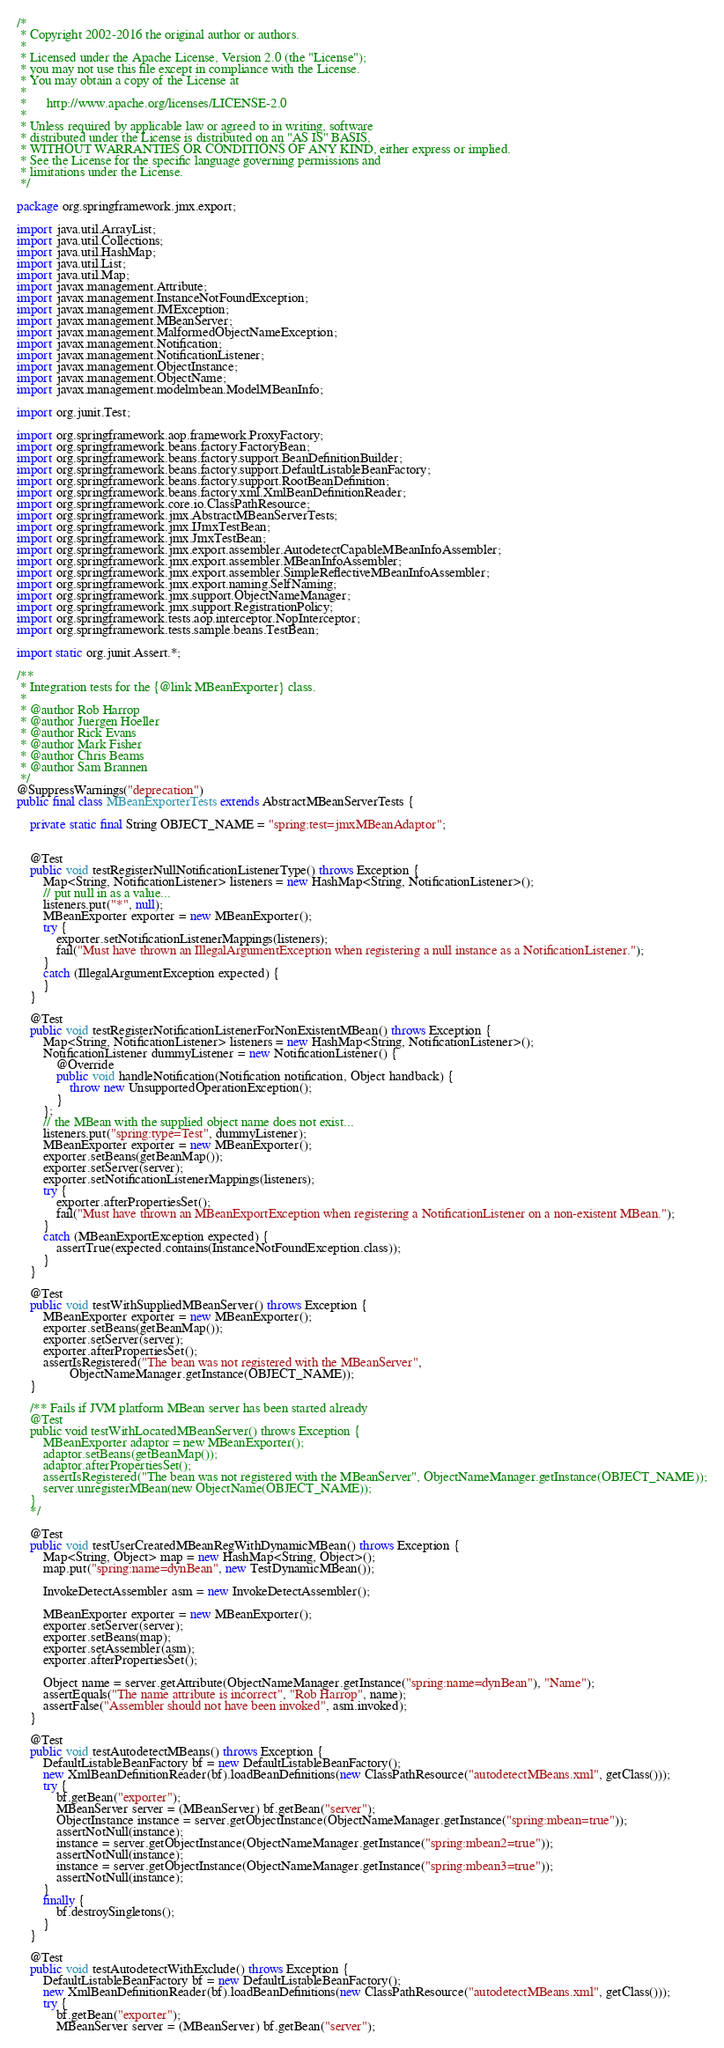Convert code to text. <code><loc_0><loc_0><loc_500><loc_500><_Java_>/*
 * Copyright 2002-2016 the original author or authors.
 *
 * Licensed under the Apache License, Version 2.0 (the "License");
 * you may not use this file except in compliance with the License.
 * You may obtain a copy of the License at
 *
 *      http://www.apache.org/licenses/LICENSE-2.0
 *
 * Unless required by applicable law or agreed to in writing, software
 * distributed under the License is distributed on an "AS IS" BASIS,
 * WITHOUT WARRANTIES OR CONDITIONS OF ANY KIND, either express or implied.
 * See the License for the specific language governing permissions and
 * limitations under the License.
 */

package org.springframework.jmx.export;

import java.util.ArrayList;
import java.util.Collections;
import java.util.HashMap;
import java.util.List;
import java.util.Map;
import javax.management.Attribute;
import javax.management.InstanceNotFoundException;
import javax.management.JMException;
import javax.management.MBeanServer;
import javax.management.MalformedObjectNameException;
import javax.management.Notification;
import javax.management.NotificationListener;
import javax.management.ObjectInstance;
import javax.management.ObjectName;
import javax.management.modelmbean.ModelMBeanInfo;

import org.junit.Test;

import org.springframework.aop.framework.ProxyFactory;
import org.springframework.beans.factory.FactoryBean;
import org.springframework.beans.factory.support.BeanDefinitionBuilder;
import org.springframework.beans.factory.support.DefaultListableBeanFactory;
import org.springframework.beans.factory.support.RootBeanDefinition;
import org.springframework.beans.factory.xml.XmlBeanDefinitionReader;
import org.springframework.core.io.ClassPathResource;
import org.springframework.jmx.AbstractMBeanServerTests;
import org.springframework.jmx.IJmxTestBean;
import org.springframework.jmx.JmxTestBean;
import org.springframework.jmx.export.assembler.AutodetectCapableMBeanInfoAssembler;
import org.springframework.jmx.export.assembler.MBeanInfoAssembler;
import org.springframework.jmx.export.assembler.SimpleReflectiveMBeanInfoAssembler;
import org.springframework.jmx.export.naming.SelfNaming;
import org.springframework.jmx.support.ObjectNameManager;
import org.springframework.jmx.support.RegistrationPolicy;
import org.springframework.tests.aop.interceptor.NopInterceptor;
import org.springframework.tests.sample.beans.TestBean;

import static org.junit.Assert.*;

/**
 * Integration tests for the {@link MBeanExporter} class.
 *
 * @author Rob Harrop
 * @author Juergen Hoeller
 * @author Rick Evans
 * @author Mark Fisher
 * @author Chris Beams
 * @author Sam Brannen
 */
@SuppressWarnings("deprecation")
public final class MBeanExporterTests extends AbstractMBeanServerTests {

	private static final String OBJECT_NAME = "spring:test=jmxMBeanAdaptor";


	@Test
	public void testRegisterNullNotificationListenerType() throws Exception {
		Map<String, NotificationListener> listeners = new HashMap<String, NotificationListener>();
		// put null in as a value...
		listeners.put("*", null);
		MBeanExporter exporter = new MBeanExporter();
		try {
			exporter.setNotificationListenerMappings(listeners);
			fail("Must have thrown an IllegalArgumentException when registering a null instance as a NotificationListener.");
		}
		catch (IllegalArgumentException expected) {
		}
	}

	@Test
	public void testRegisterNotificationListenerForNonExistentMBean() throws Exception {
		Map<String, NotificationListener> listeners = new HashMap<String, NotificationListener>();
		NotificationListener dummyListener = new NotificationListener() {
			@Override
			public void handleNotification(Notification notification, Object handback) {
				throw new UnsupportedOperationException();
			}
		};
		// the MBean with the supplied object name does not exist...
		listeners.put("spring:type=Test", dummyListener);
		MBeanExporter exporter = new MBeanExporter();
		exporter.setBeans(getBeanMap());
		exporter.setServer(server);
		exporter.setNotificationListenerMappings(listeners);
		try {
			exporter.afterPropertiesSet();
			fail("Must have thrown an MBeanExportException when registering a NotificationListener on a non-existent MBean.");
		}
		catch (MBeanExportException expected) {
			assertTrue(expected.contains(InstanceNotFoundException.class));
		}
	}

	@Test
	public void testWithSuppliedMBeanServer() throws Exception {
		MBeanExporter exporter = new MBeanExporter();
		exporter.setBeans(getBeanMap());
		exporter.setServer(server);
		exporter.afterPropertiesSet();
		assertIsRegistered("The bean was not registered with the MBeanServer",
				ObjectNameManager.getInstance(OBJECT_NAME));
	}

	/** Fails if JVM platform MBean server has been started already
	@Test
	public void testWithLocatedMBeanServer() throws Exception {
		MBeanExporter adaptor = new MBeanExporter();
		adaptor.setBeans(getBeanMap());
		adaptor.afterPropertiesSet();
		assertIsRegistered("The bean was not registered with the MBeanServer", ObjectNameManager.getInstance(OBJECT_NAME));
		server.unregisterMBean(new ObjectName(OBJECT_NAME));
	}
	*/

	@Test
	public void testUserCreatedMBeanRegWithDynamicMBean() throws Exception {
		Map<String, Object> map = new HashMap<String, Object>();
		map.put("spring:name=dynBean", new TestDynamicMBean());

		InvokeDetectAssembler asm = new InvokeDetectAssembler();

		MBeanExporter exporter = new MBeanExporter();
		exporter.setServer(server);
		exporter.setBeans(map);
		exporter.setAssembler(asm);
		exporter.afterPropertiesSet();

		Object name = server.getAttribute(ObjectNameManager.getInstance("spring:name=dynBean"), "Name");
		assertEquals("The name attribute is incorrect", "Rob Harrop", name);
		assertFalse("Assembler should not have been invoked", asm.invoked);
	}

	@Test
	public void testAutodetectMBeans() throws Exception {
		DefaultListableBeanFactory bf = new DefaultListableBeanFactory();
		new XmlBeanDefinitionReader(bf).loadBeanDefinitions(new ClassPathResource("autodetectMBeans.xml", getClass()));
		try {
			bf.getBean("exporter");
			MBeanServer server = (MBeanServer) bf.getBean("server");
			ObjectInstance instance = server.getObjectInstance(ObjectNameManager.getInstance("spring:mbean=true"));
			assertNotNull(instance);
			instance = server.getObjectInstance(ObjectNameManager.getInstance("spring:mbean2=true"));
			assertNotNull(instance);
			instance = server.getObjectInstance(ObjectNameManager.getInstance("spring:mbean3=true"));
			assertNotNull(instance);
		}
		finally {
			bf.destroySingletons();
		}
	}

	@Test
	public void testAutodetectWithExclude() throws Exception {
		DefaultListableBeanFactory bf = new DefaultListableBeanFactory();
		new XmlBeanDefinitionReader(bf).loadBeanDefinitions(new ClassPathResource("autodetectMBeans.xml", getClass()));
		try {
			bf.getBean("exporter");
			MBeanServer server = (MBeanServer) bf.getBean("server");</code> 